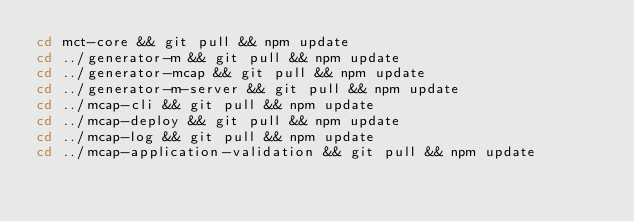Convert code to text. <code><loc_0><loc_0><loc_500><loc_500><_Bash_>cd mct-core && git pull && npm update
cd ../generator-m && git pull && npm update
cd ../generator-mcap && git pull && npm update
cd ../generator-m-server && git pull && npm update
cd ../mcap-cli && git pull && npm update
cd ../mcap-deploy && git pull && npm update
cd ../mcap-log && git pull && npm update
cd ../mcap-application-validation && git pull && npm update</code> 